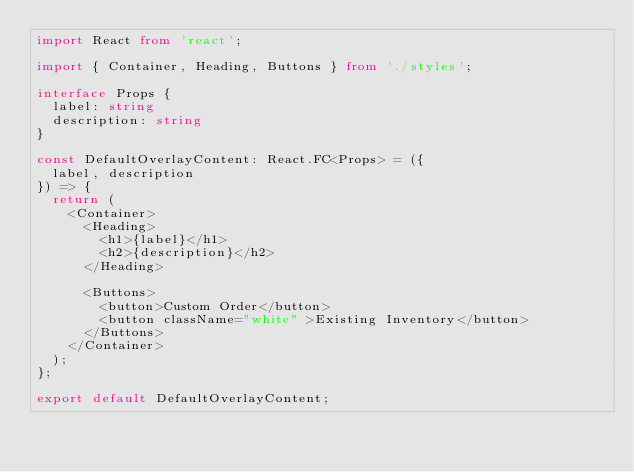<code> <loc_0><loc_0><loc_500><loc_500><_TypeScript_>import React from 'react';

import { Container, Heading, Buttons } from './styles';

interface Props {
  label: string
  description: string
}

const DefaultOverlayContent: React.FC<Props> = ({
  label, description
}) => {
  return (
    <Container>
      <Heading>
        <h1>{label}</h1>
        <h2>{description}</h2>
      </Heading>

      <Buttons>
        <button>Custom Order</button>
        <button className="white" >Existing Inventory</button>
      </Buttons>
    </Container>
  );
};

export default DefaultOverlayContent;</code> 